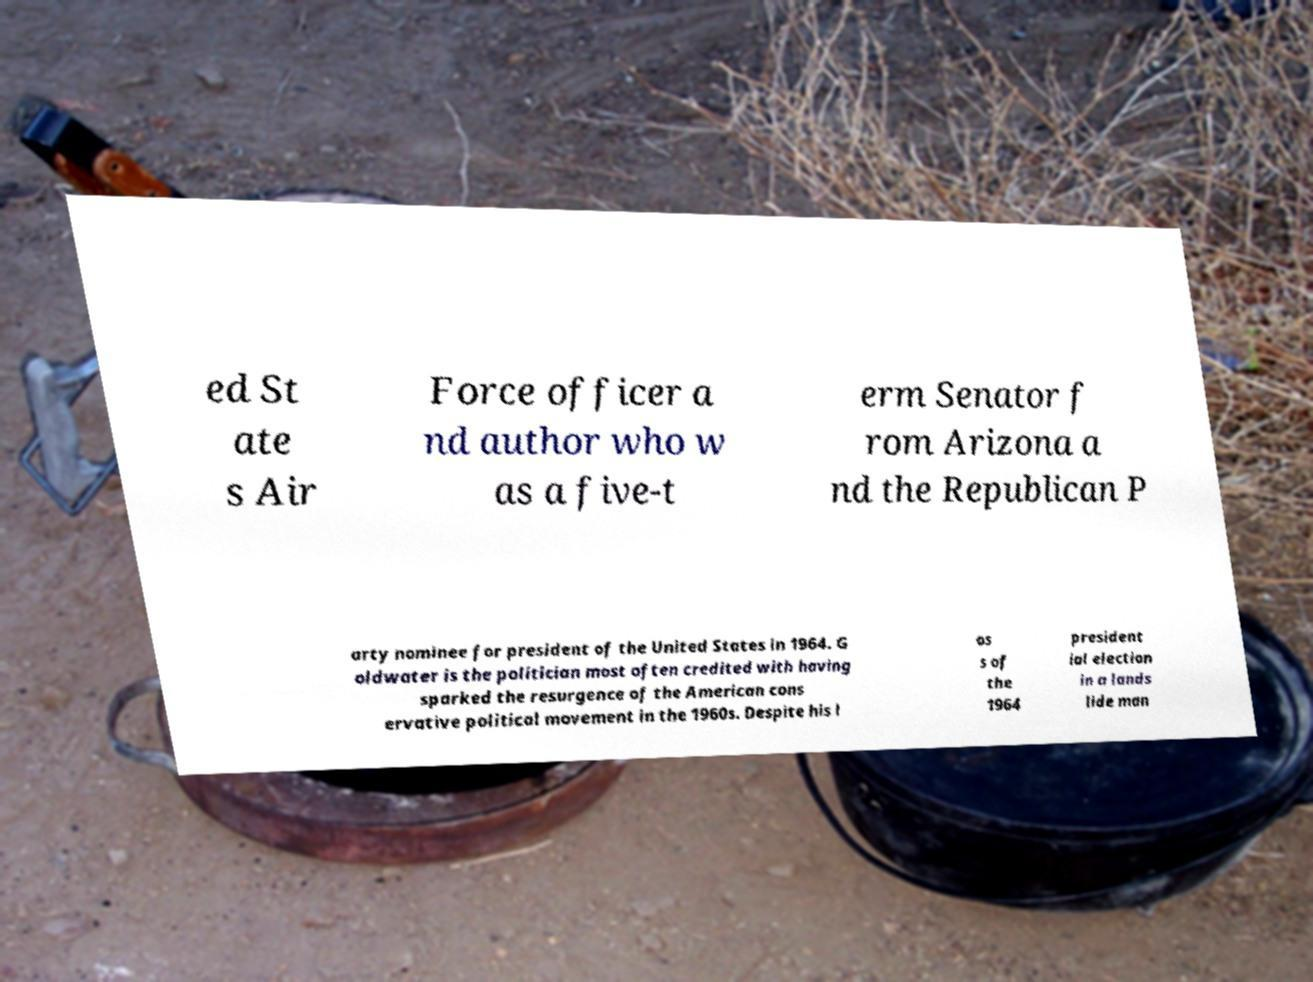For documentation purposes, I need the text within this image transcribed. Could you provide that? ed St ate s Air Force officer a nd author who w as a five-t erm Senator f rom Arizona a nd the Republican P arty nominee for president of the United States in 1964. G oldwater is the politician most often credited with having sparked the resurgence of the American cons ervative political movement in the 1960s. Despite his l os s of the 1964 president ial election in a lands lide man 